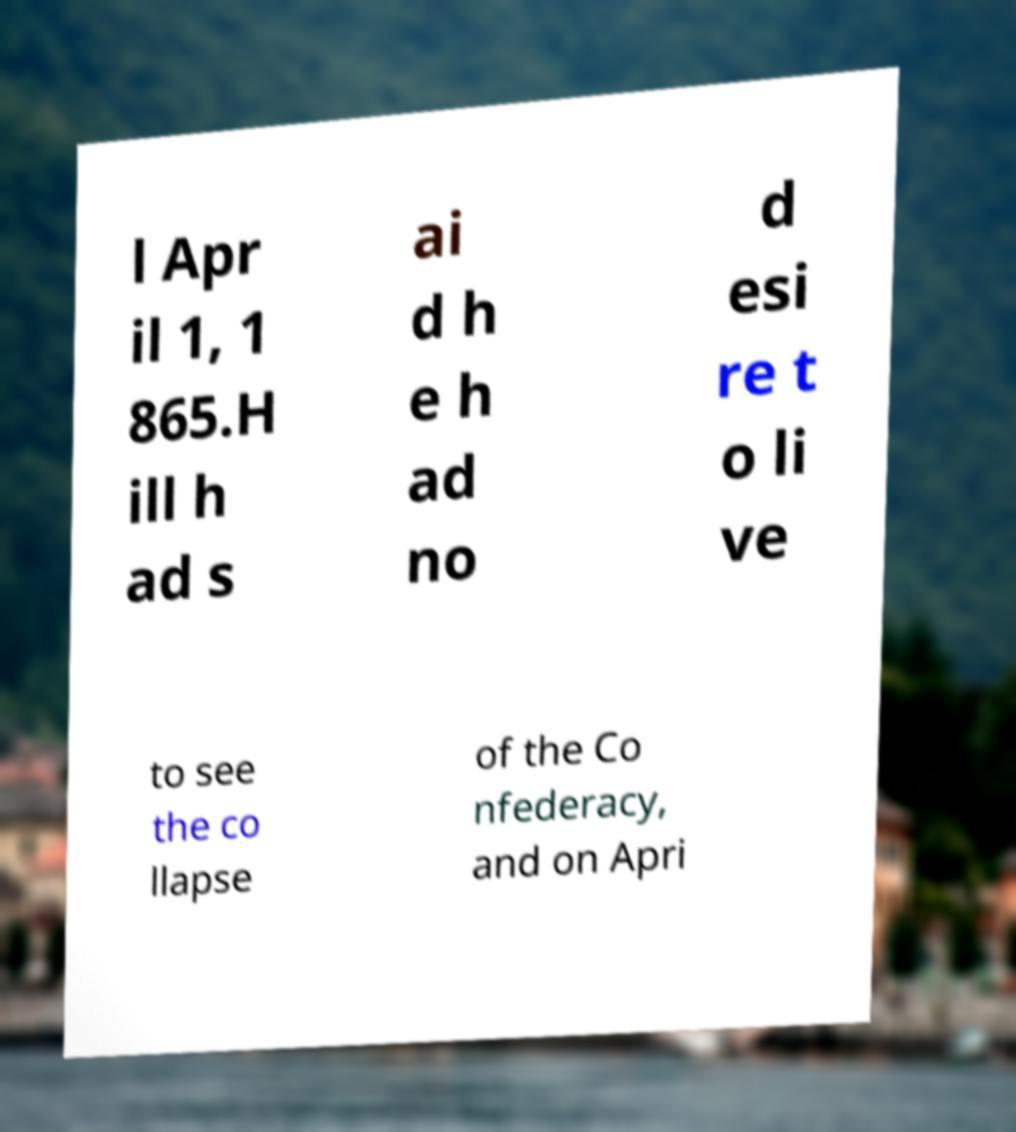There's text embedded in this image that I need extracted. Can you transcribe it verbatim? l Apr il 1, 1 865.H ill h ad s ai d h e h ad no d esi re t o li ve to see the co llapse of the Co nfederacy, and on Apri 